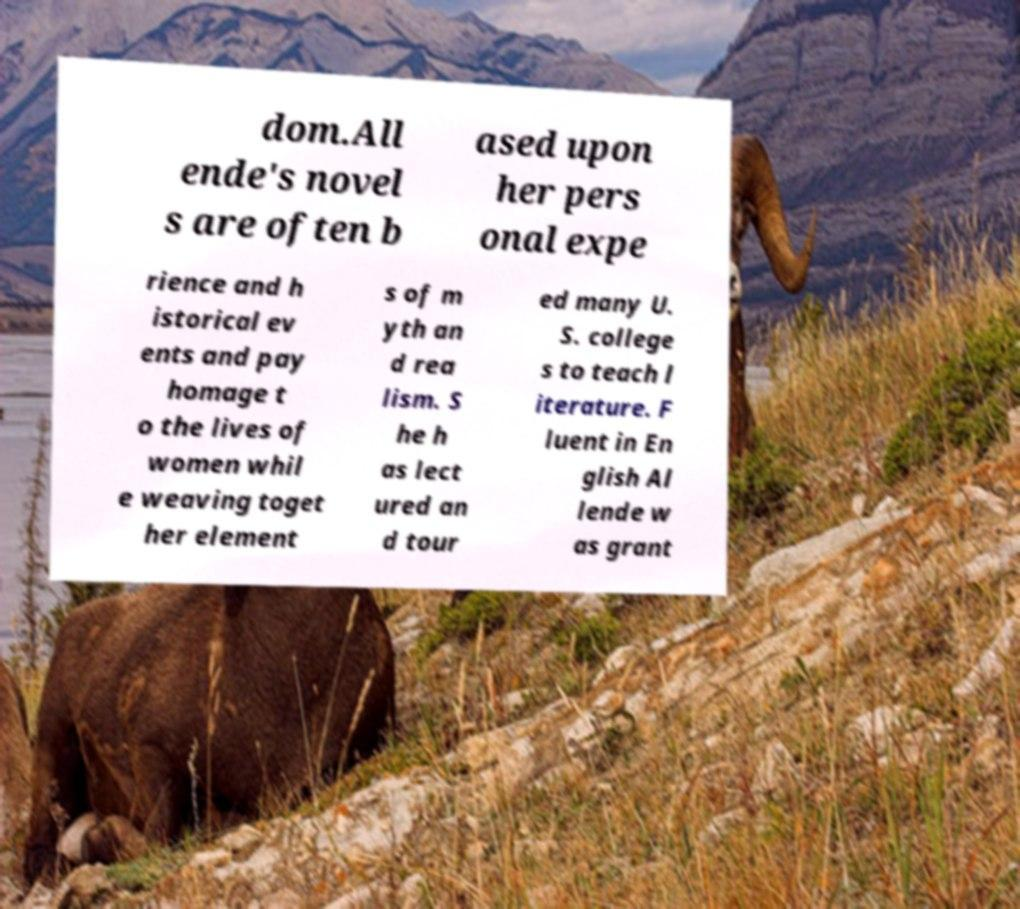Could you extract and type out the text from this image? dom.All ende's novel s are often b ased upon her pers onal expe rience and h istorical ev ents and pay homage t o the lives of women whil e weaving toget her element s of m yth an d rea lism. S he h as lect ured an d tour ed many U. S. college s to teach l iterature. F luent in En glish Al lende w as grant 